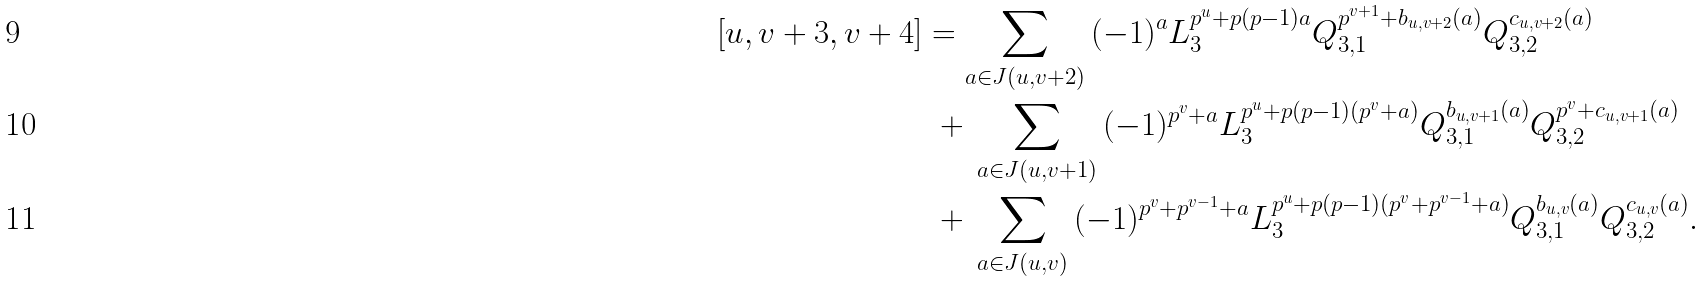Convert formula to latex. <formula><loc_0><loc_0><loc_500><loc_500>[ u , v + 3 , v + 4 ] & = \sum _ { a \in J ( u , v + 2 ) } \, ( - 1 ) ^ { a } L _ { 3 } ^ { p ^ { u } + p ( p - 1 ) a } Q _ { 3 , 1 } ^ { p ^ { v + 1 } + b _ { u , v + 2 } ( a ) } Q _ { 3 , 2 } ^ { c _ { u , v + 2 } ( a ) } \\ & \ + \, \sum _ { a \in J ( u , v + 1 ) } \, ( - 1 ) ^ { p ^ { v } + a } L _ { 3 } ^ { p ^ { u } + p ( p - 1 ) ( p ^ { v } + a ) } Q _ { 3 , 1 } ^ { b _ { u , v + 1 } ( a ) } Q _ { 3 , 2 } ^ { p ^ { v } + c _ { u , v + 1 } ( a ) } \\ & \ + \, \sum _ { a \in J ( u , v ) } \, ( - 1 ) ^ { p ^ { v } + p ^ { v - 1 } + a } L _ { 3 } ^ { p ^ { u } + p ( p - 1 ) ( p ^ { v } + p ^ { v - 1 } + a ) } Q _ { 3 , 1 } ^ { b _ { u , v } ( a ) } Q _ { 3 , 2 } ^ { c _ { u , v } ( a ) } .</formula> 